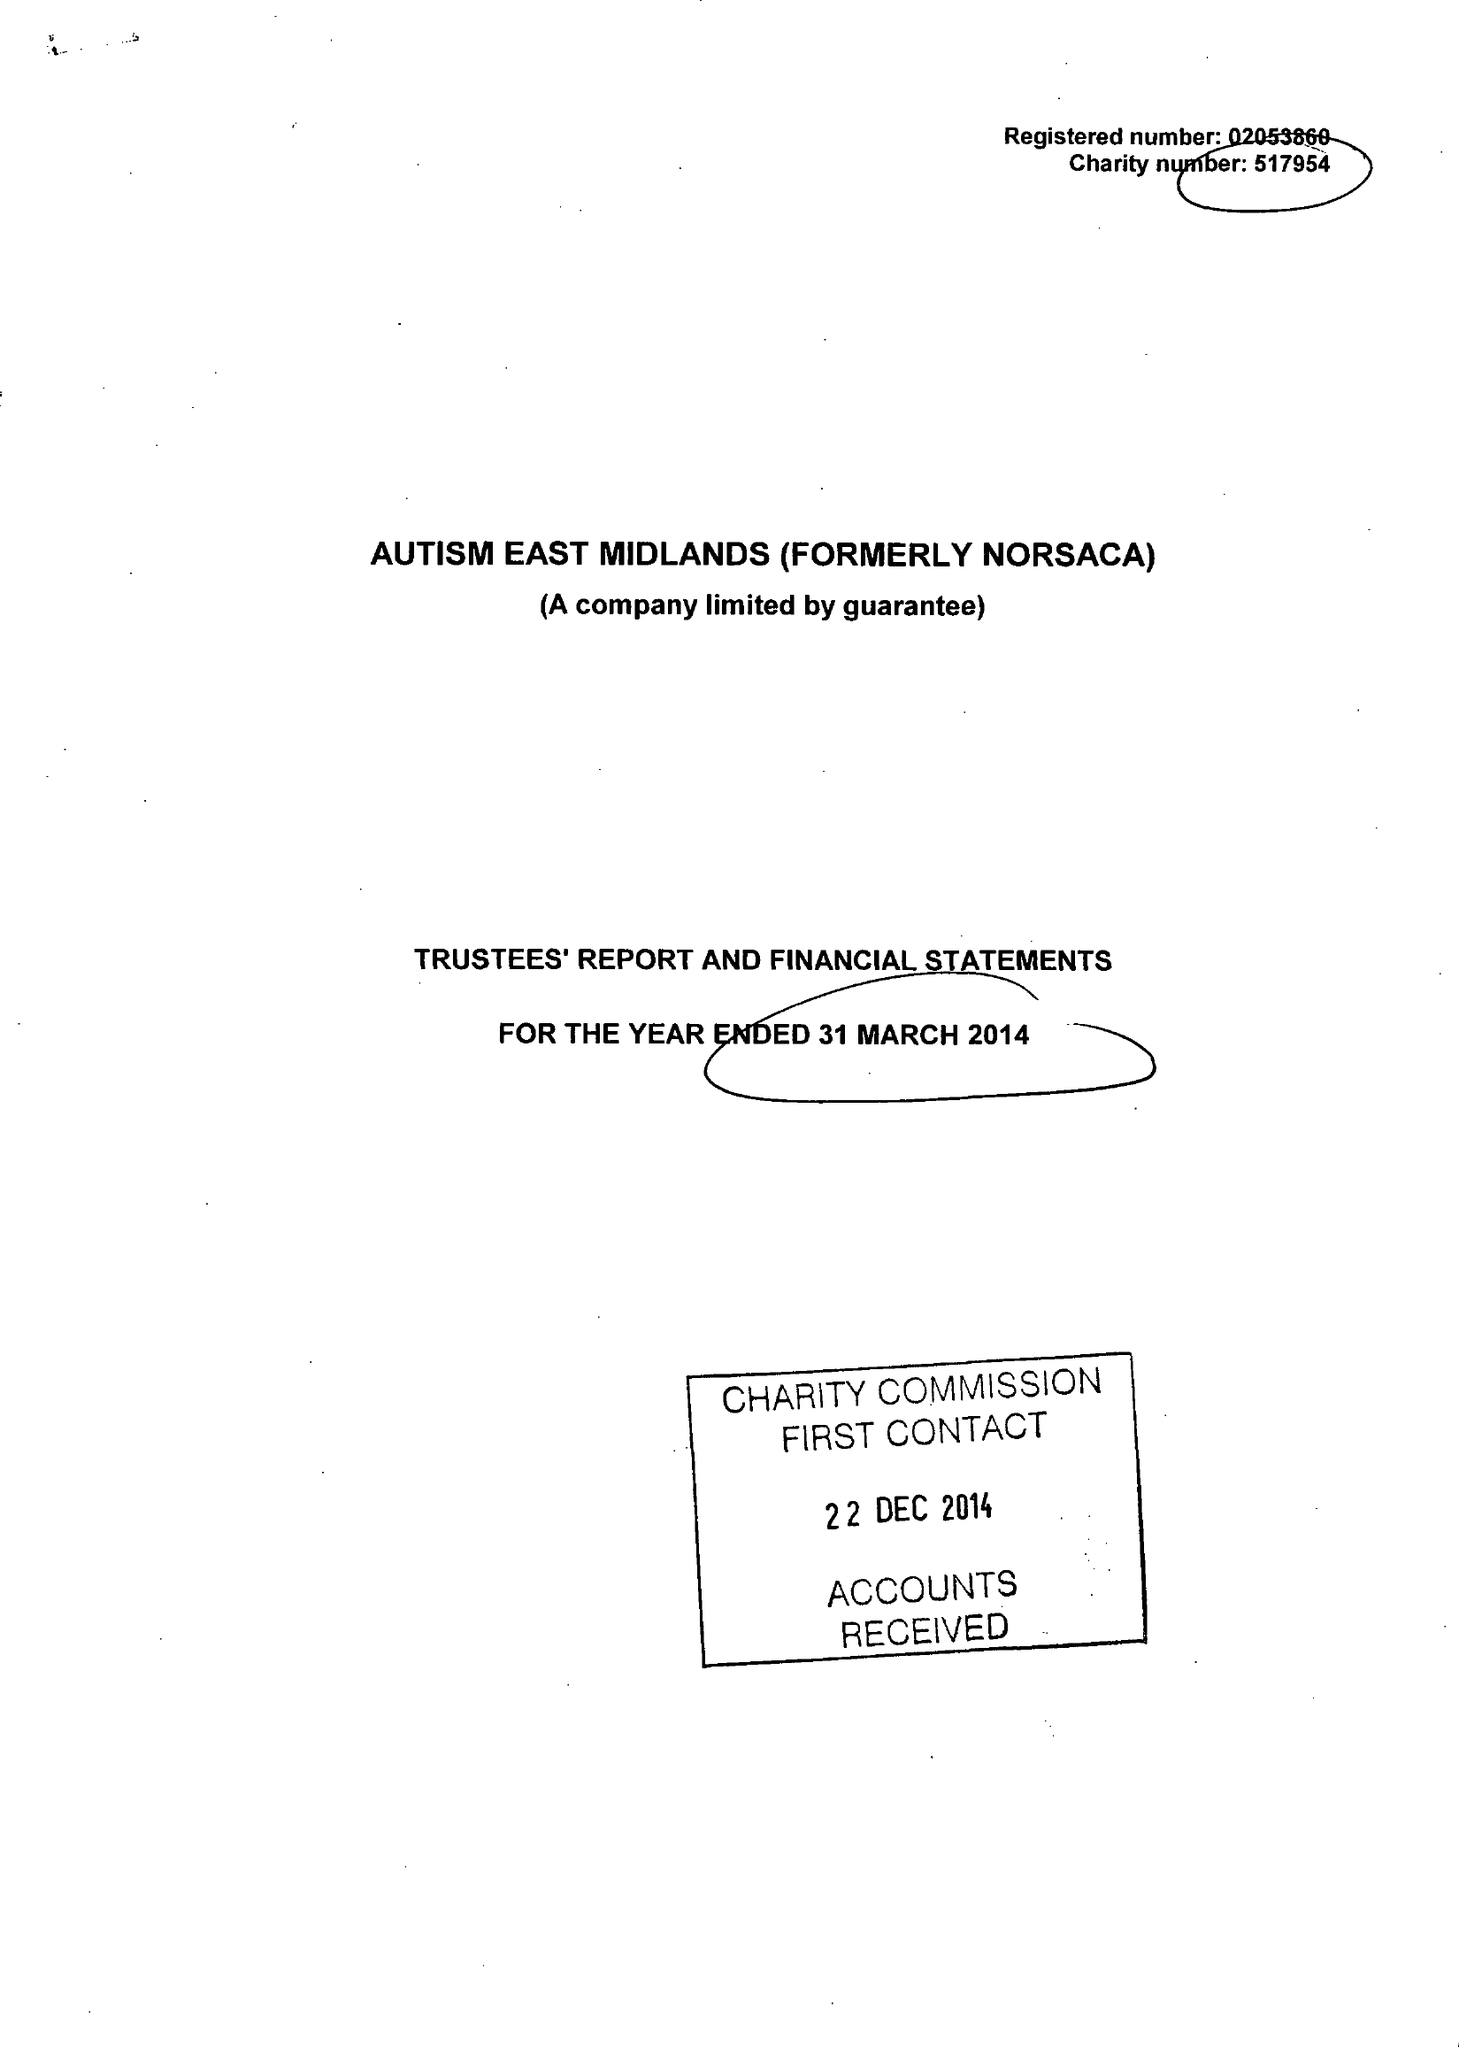What is the value for the report_date?
Answer the question using a single word or phrase. 2014-03-31 